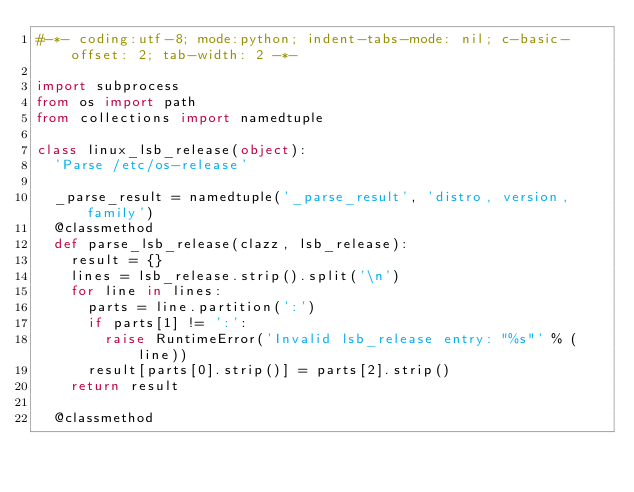Convert code to text. <code><loc_0><loc_0><loc_500><loc_500><_Python_>#-*- coding:utf-8; mode:python; indent-tabs-mode: nil; c-basic-offset: 2; tab-width: 2 -*-

import subprocess
from os import path
from collections import namedtuple

class linux_lsb_release(object):
  'Parse /etc/os-release'

  _parse_result = namedtuple('_parse_result', 'distro, version, family')
  @classmethod
  def parse_lsb_release(clazz, lsb_release):
    result = {}
    lines = lsb_release.strip().split('\n')
    for line in lines:
      parts = line.partition(':')
      if parts[1] != ':':
        raise RuntimeError('Invalid lsb_release entry: "%s"' % (line))
      result[parts[0].strip()] = parts[2].strip()
    return result

  @classmethod</code> 